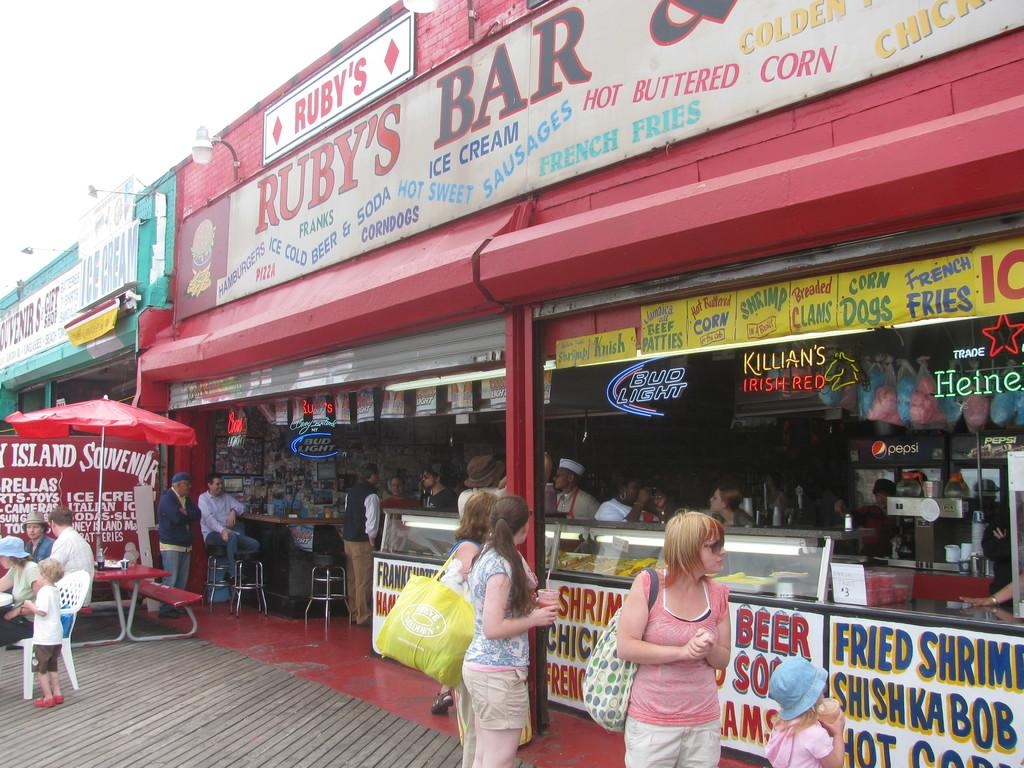<image>
Create a compact narrative representing the image presented. People standing next to a food stall that says Ruby's on it. 